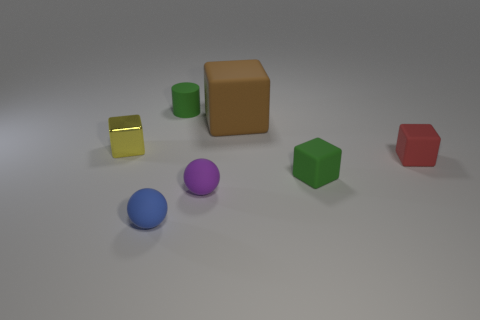Add 2 cyan blocks. How many objects exist? 9 Subtract all yellow cubes. How many cubes are left? 3 Subtract all brown blocks. How many blocks are left? 3 Subtract 2 cubes. How many cubes are left? 2 Subtract 1 green cylinders. How many objects are left? 6 Subtract all cubes. How many objects are left? 3 Subtract all red balls. Subtract all purple cubes. How many balls are left? 2 Subtract all tiny yellow things. Subtract all cyan blocks. How many objects are left? 6 Add 7 large matte things. How many large matte things are left? 8 Add 6 big yellow rubber balls. How many big yellow rubber balls exist? 6 